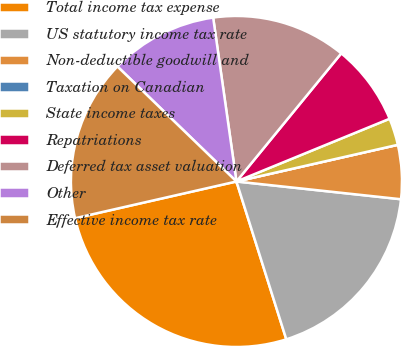Convert chart. <chart><loc_0><loc_0><loc_500><loc_500><pie_chart><fcel>Total income tax expense<fcel>US statutory income tax rate<fcel>Non-deductible goodwill and<fcel>Taxation on Canadian<fcel>State income taxes<fcel>Repatriations<fcel>Deferred tax asset valuation<fcel>Other<fcel>Effective income tax rate<nl><fcel>26.31%<fcel>18.42%<fcel>5.27%<fcel>0.0%<fcel>2.63%<fcel>7.9%<fcel>13.16%<fcel>10.53%<fcel>15.79%<nl></chart> 